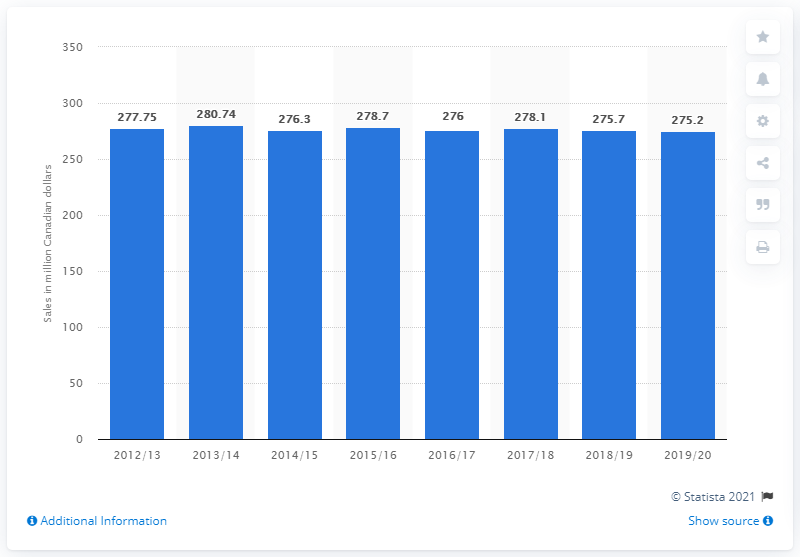Give some essential details in this illustration. In the fiscal year 2019/20, the sales of beer in Nova Scotia totaled 275.2 million units. 